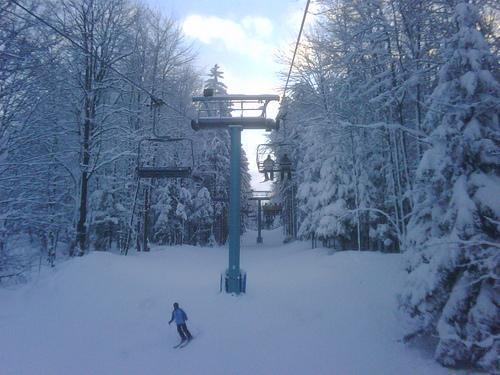Where are the people on the wire going?
From the following four choices, select the correct answer to address the question.
Options: Home, gift shop, bus stop, summit. Summit. 